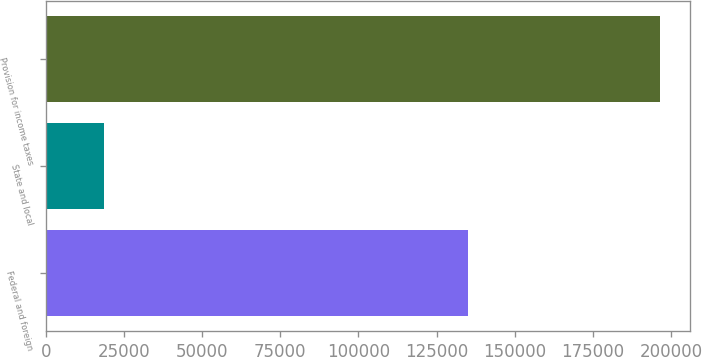Convert chart. <chart><loc_0><loc_0><loc_500><loc_500><bar_chart><fcel>Federal and foreign<fcel>State and local<fcel>Provision for income taxes<nl><fcel>135215<fcel>18764<fcel>196426<nl></chart> 